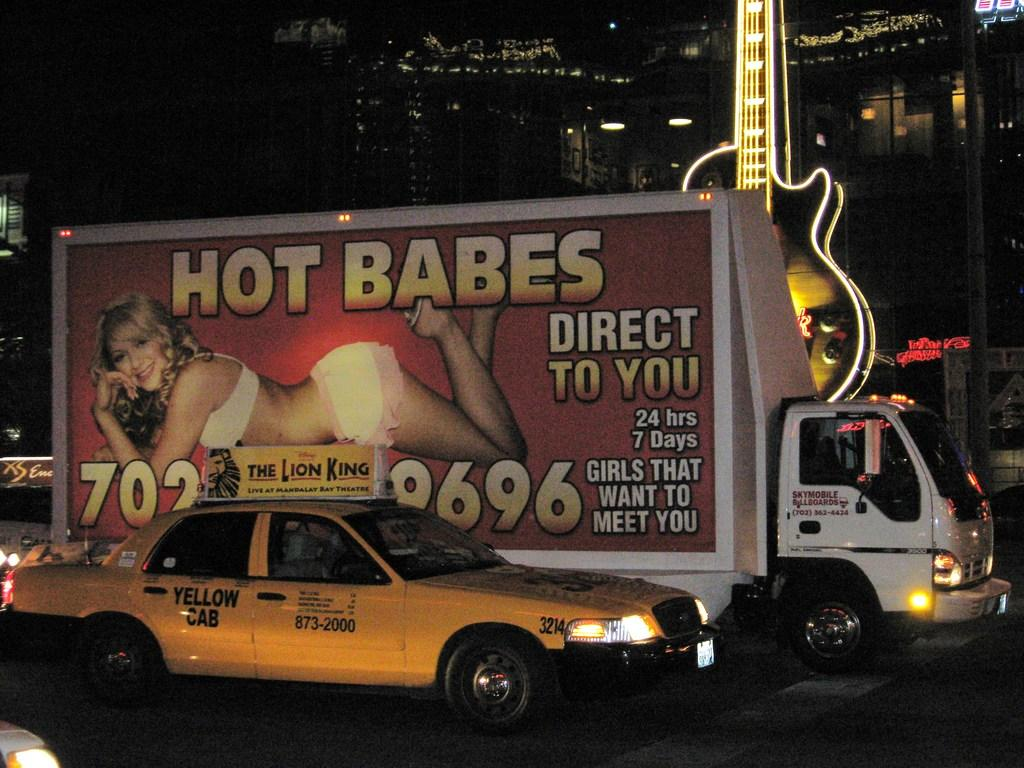<image>
Create a compact narrative representing the image presented. A Yellow Cab company taxi is in front of a white truck. 